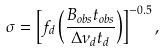Convert formula to latex. <formula><loc_0><loc_0><loc_500><loc_500>\sigma = \left [ f _ { d } \left ( \frac { B _ { o b s } t _ { o b s } } { \Delta \nu _ { d } t _ { d } } \right ) \right ] ^ { - 0 . 5 } ,</formula> 